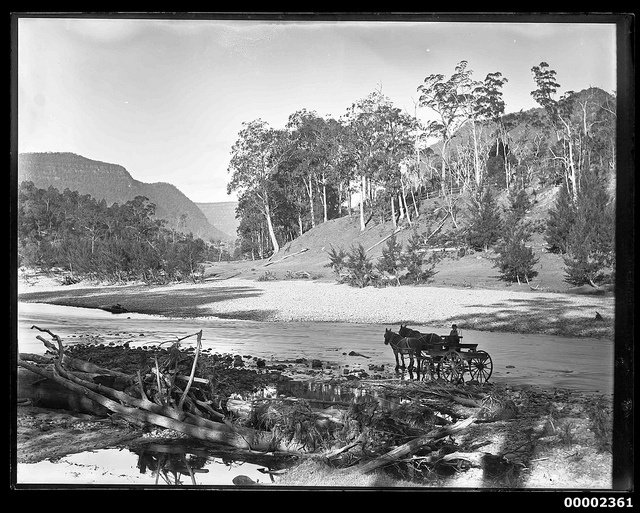Describe the objects in this image and their specific colors. I can see horse in black, gray, darkgray, and lightgray tones, horse in black, gray, darkgray, and lightgray tones, and people in gray and black tones in this image. 